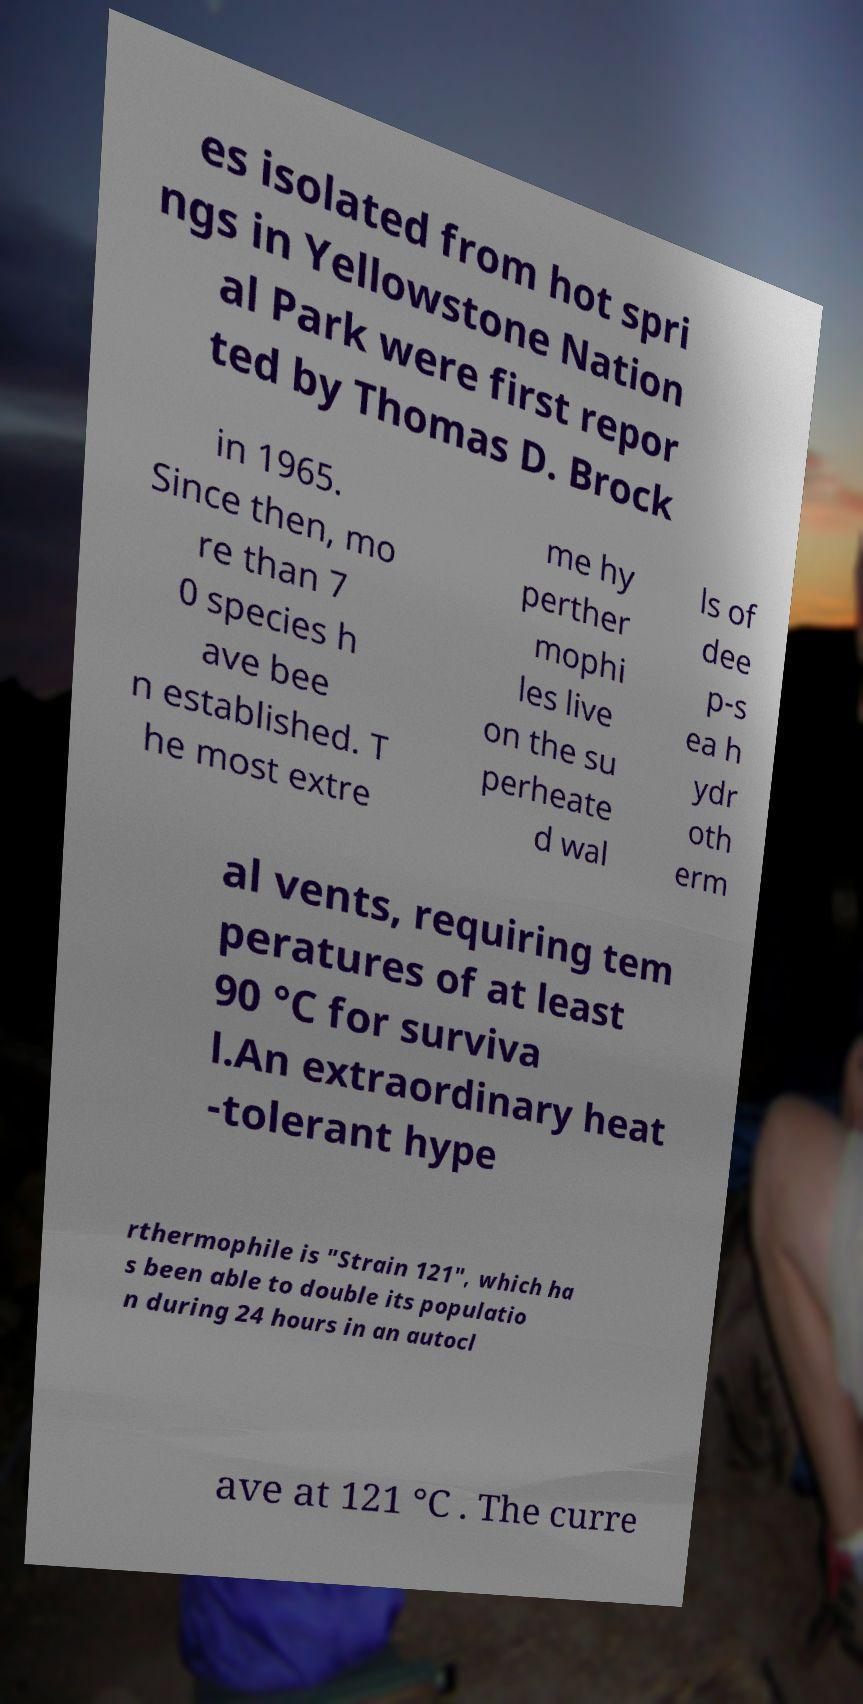Can you read and provide the text displayed in the image?This photo seems to have some interesting text. Can you extract and type it out for me? es isolated from hot spri ngs in Yellowstone Nation al Park were first repor ted by Thomas D. Brock in 1965. Since then, mo re than 7 0 species h ave bee n established. T he most extre me hy perther mophi les live on the su perheate d wal ls of dee p-s ea h ydr oth erm al vents, requiring tem peratures of at least 90 °C for surviva l.An extraordinary heat -tolerant hype rthermophile is "Strain 121", which ha s been able to double its populatio n during 24 hours in an autocl ave at 121 °C . The curre 